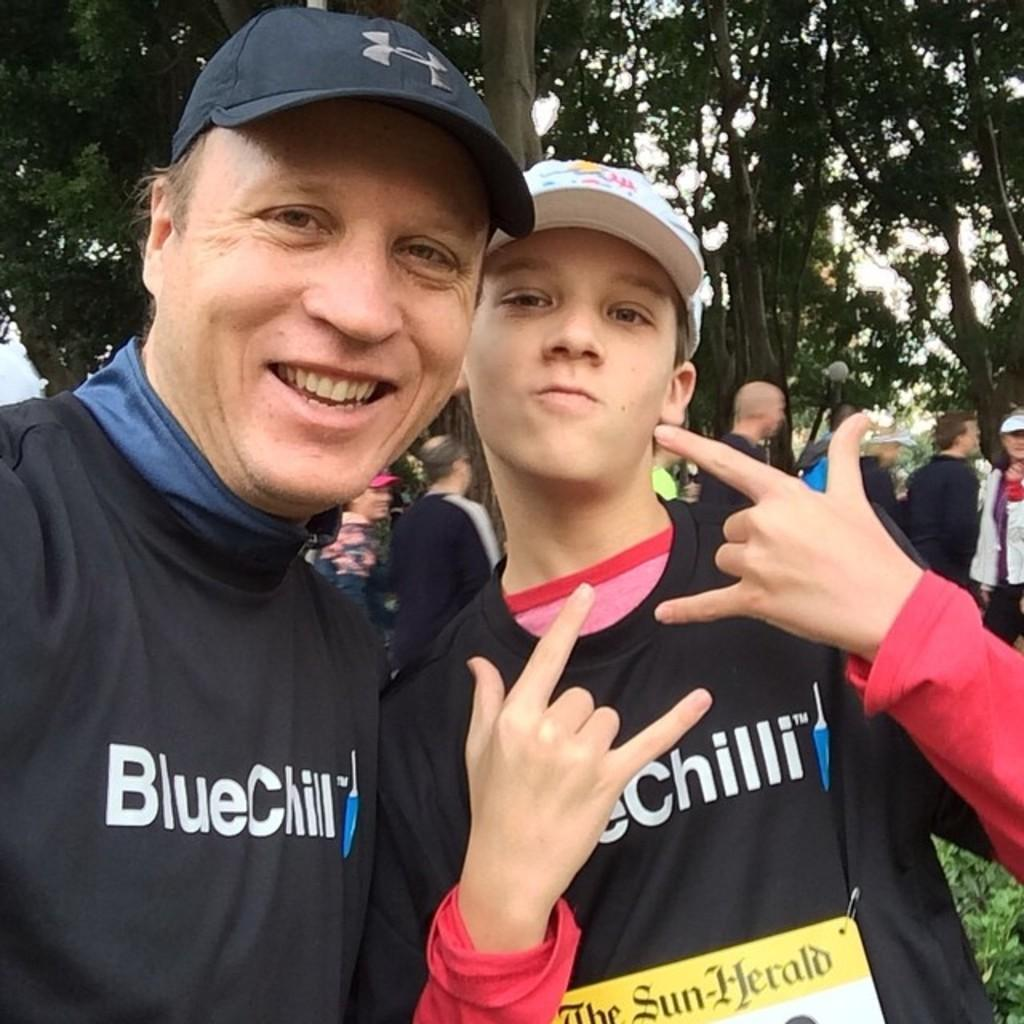What is the main subject of the image? The main subject of the image is a group of people. Where are the people located in the image? The people are standing on the ground. What type of vegetation can be seen on the right side of the image? There are plants on the right side of the image. What is visible at the top of the image? There is a group of trees visible at the top of the image. Can you tell me how many times the people in the image sneeze? There is no indication in the image that the people are sneezing, so it cannot be determined from the picture. 